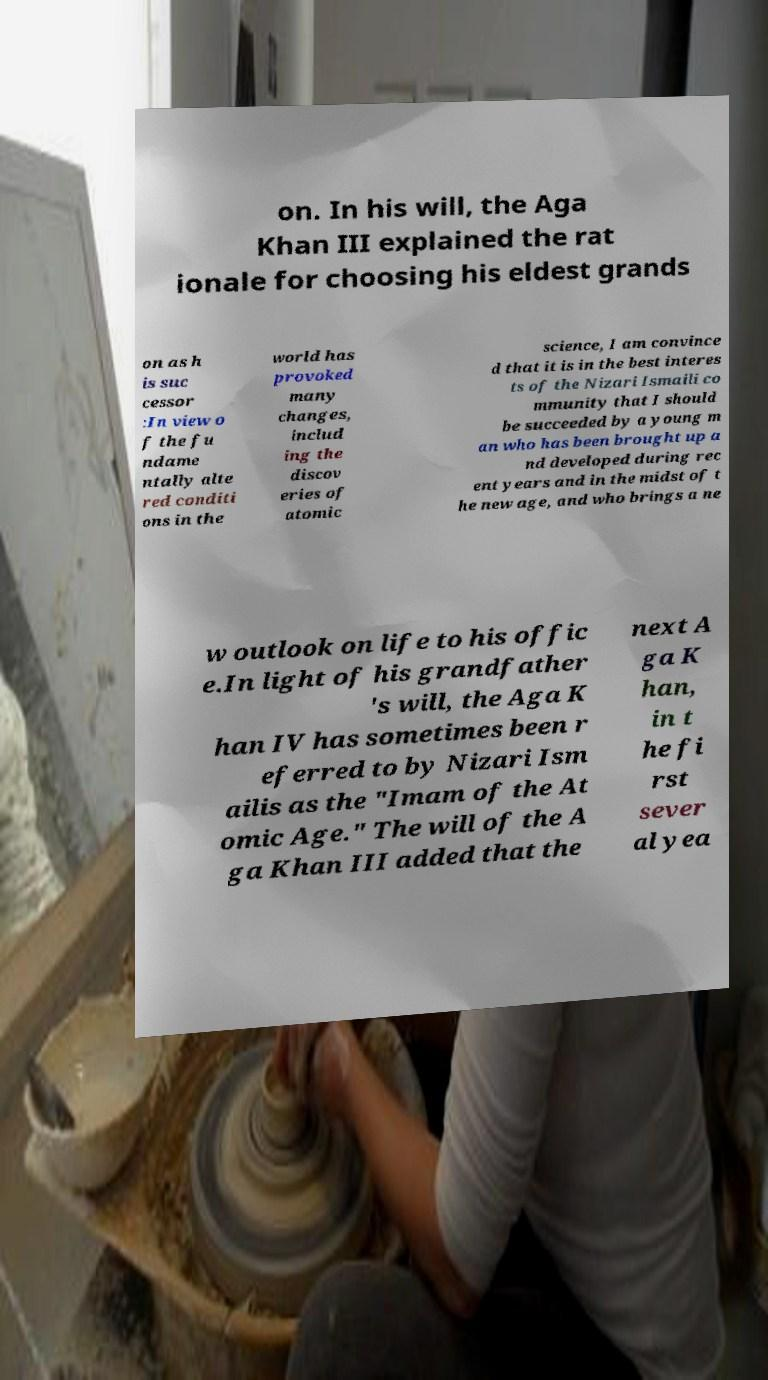Can you read and provide the text displayed in the image?This photo seems to have some interesting text. Can you extract and type it out for me? on. In his will, the Aga Khan III explained the rat ionale for choosing his eldest grands on as h is suc cessor :In view o f the fu ndame ntally alte red conditi ons in the world has provoked many changes, includ ing the discov eries of atomic science, I am convince d that it is in the best interes ts of the Nizari Ismaili co mmunity that I should be succeeded by a young m an who has been brought up a nd developed during rec ent years and in the midst of t he new age, and who brings a ne w outlook on life to his offic e.In light of his grandfather 's will, the Aga K han IV has sometimes been r eferred to by Nizari Ism ailis as the "Imam of the At omic Age." The will of the A ga Khan III added that the next A ga K han, in t he fi rst sever al yea 